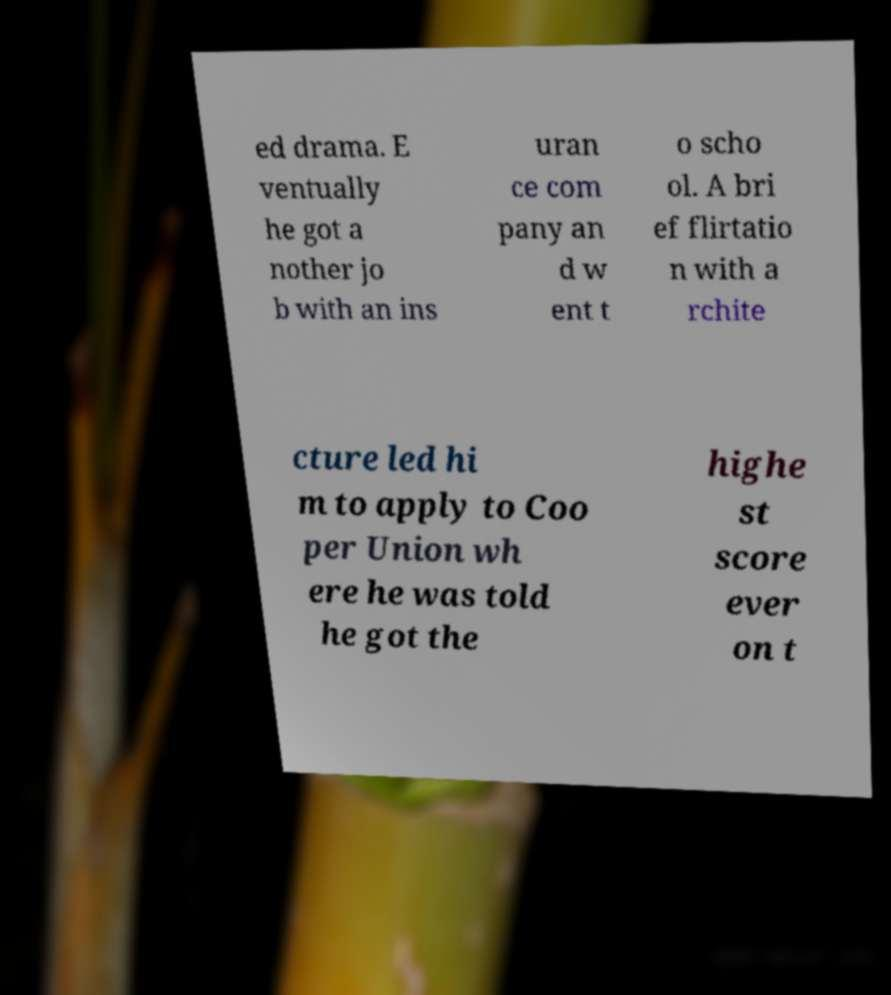I need the written content from this picture converted into text. Can you do that? ed drama. E ventually he got a nother jo b with an ins uran ce com pany an d w ent t o scho ol. A bri ef flirtatio n with a rchite cture led hi m to apply to Coo per Union wh ere he was told he got the highe st score ever on t 